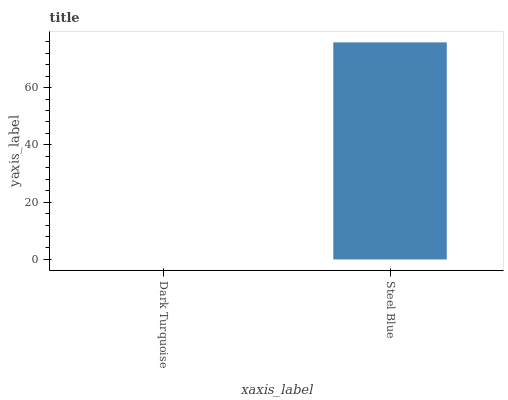Is Dark Turquoise the minimum?
Answer yes or no. Yes. Is Steel Blue the maximum?
Answer yes or no. Yes. Is Steel Blue the minimum?
Answer yes or no. No. Is Steel Blue greater than Dark Turquoise?
Answer yes or no. Yes. Is Dark Turquoise less than Steel Blue?
Answer yes or no. Yes. Is Dark Turquoise greater than Steel Blue?
Answer yes or no. No. Is Steel Blue less than Dark Turquoise?
Answer yes or no. No. Is Steel Blue the high median?
Answer yes or no. Yes. Is Dark Turquoise the low median?
Answer yes or no. Yes. Is Dark Turquoise the high median?
Answer yes or no. No. Is Steel Blue the low median?
Answer yes or no. No. 